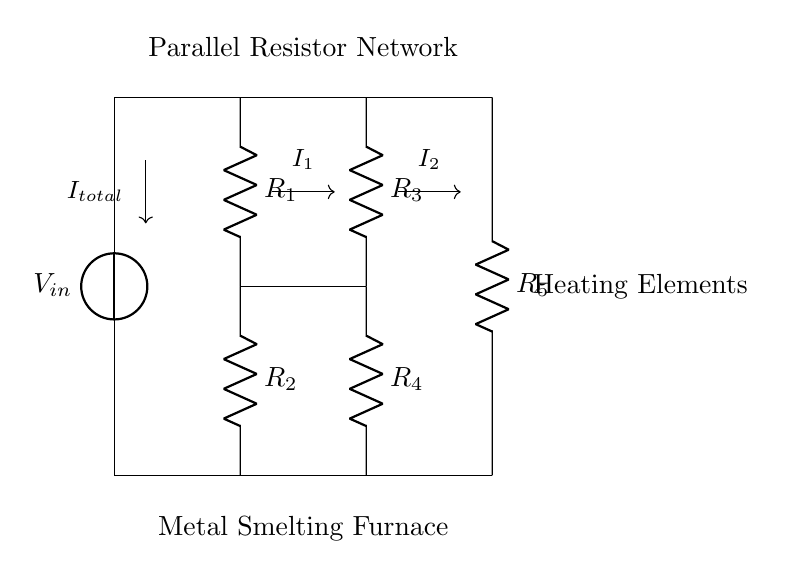What is the total number of resistors in the circuit? The circuit consists of five resistors labeled R1, R2, R3, R4, and R5. Counting these components gives a total of 5 resistors.
Answer: 5 What is the configuration of the resistors in this circuit? The resistors are arranged in parallel, which can be identified by the multiple branches connecting to the same input and output voltage.
Answer: Parallel What is the current entering the circuit labeled as? The current entering the circuit is denoted as I_total, which is indicated by the arrow pointing into the circuit from the voltage source.
Answer: I_total How many branches are present in the parallel resistor network? There are three pairs of resistors that form two branches in the parallel configuration (one branch for R1 and R2, and another for R3 and R4), and a single branch for R5. Thus, there are three branches total.
Answer: 3 Which resistors are in the same branch of the circuit? Resistors R1 and R2 are connected in series, thus they form one branch together. Resistors R3 and R4 are also in series, forming another branch. This leaves R5 as a stand-alone branch.
Answer: R1, R2; R3, R4 What is the purpose of the parallel resistor network? The parallel resistor network allows for precise control of the current flowing through each heating element in the metal smelting furnace, enabling better temperature regulation and management.
Answer: Current control 